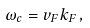<formula> <loc_0><loc_0><loc_500><loc_500>\omega _ { c } = v _ { F } k _ { F } \, ,</formula> 